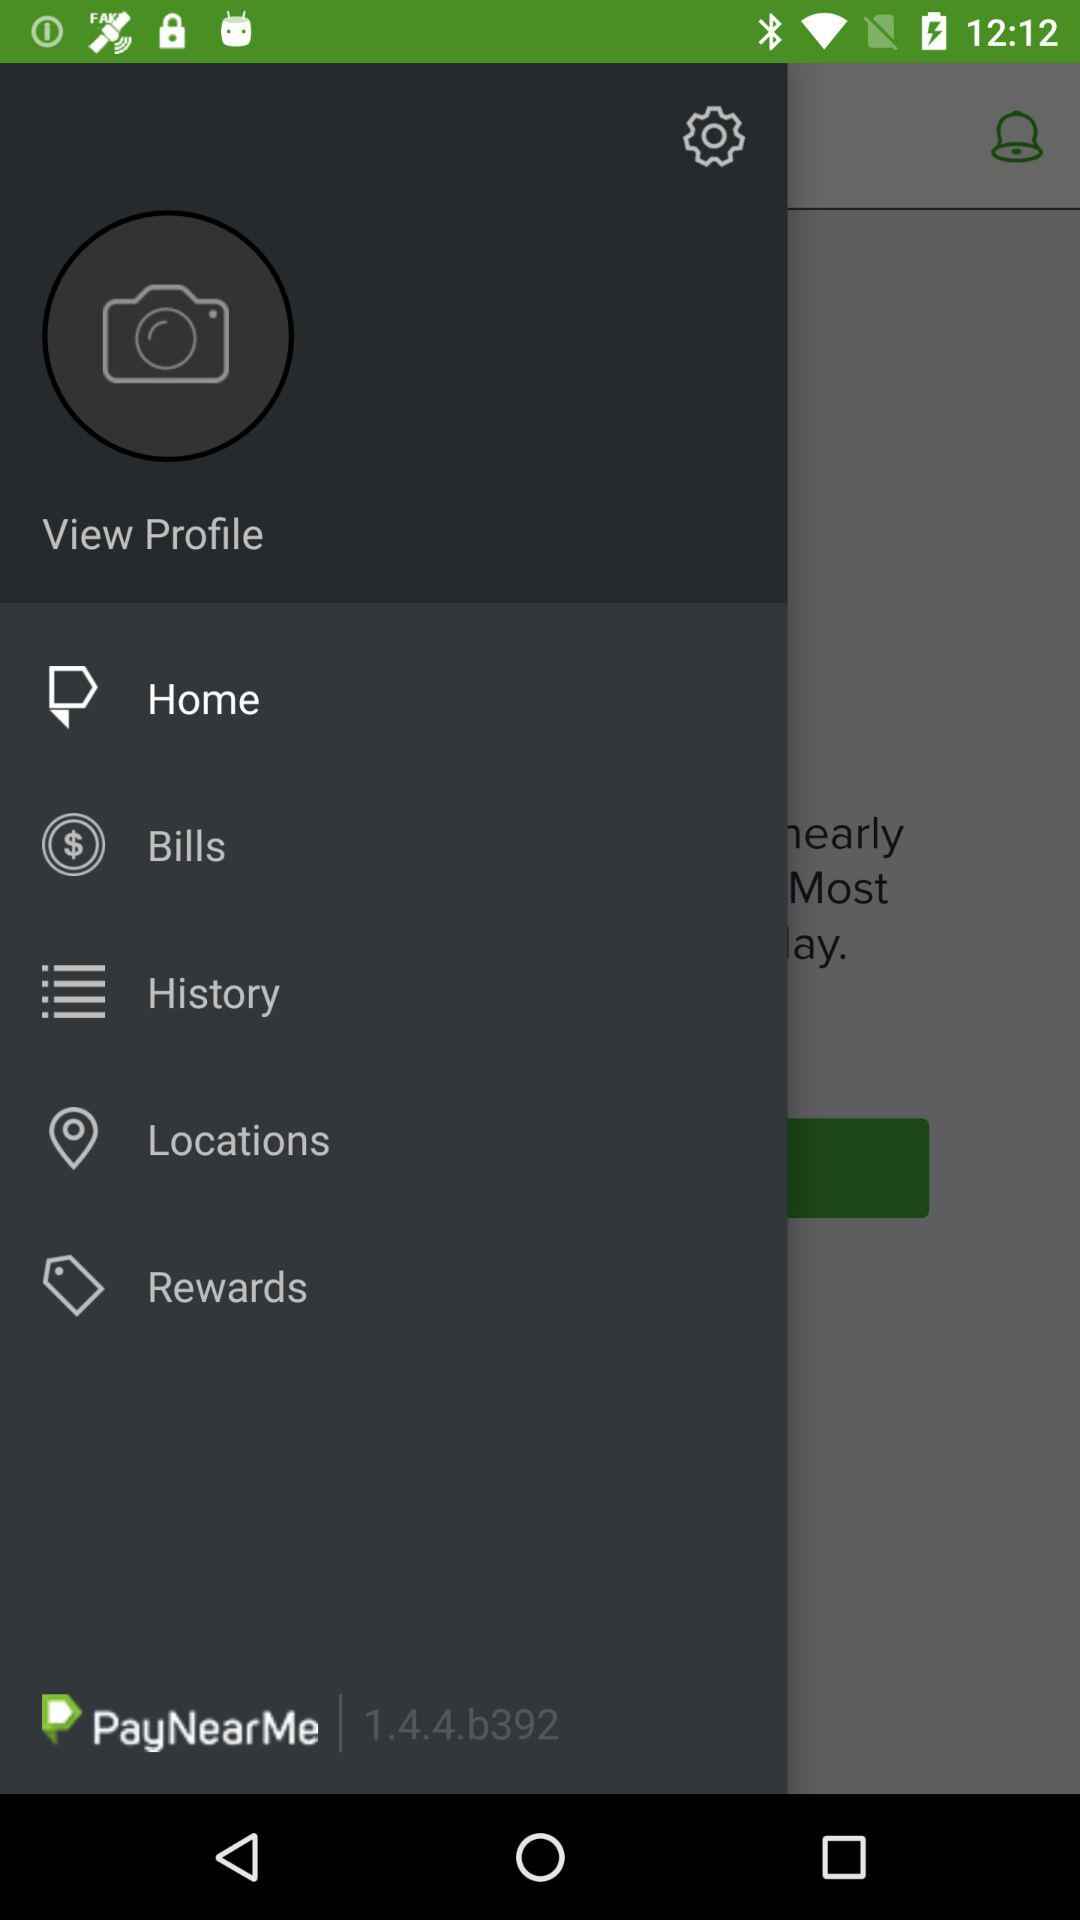What is the version of the application being used? The version is 1.4.4.b392. 